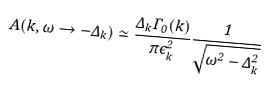<formula> <loc_0><loc_0><loc_500><loc_500>A ( { k } , \omega \rightarrow - \Delta _ { k } ) \simeq \frac { \Delta _ { k } \Gamma _ { 0 } ( { k } ) } { \pi \epsilon ^ { 2 } _ { k } } \frac { 1 } { \sqrt { \omega ^ { 2 } - \Delta _ { k } ^ { 2 } } }</formula> 